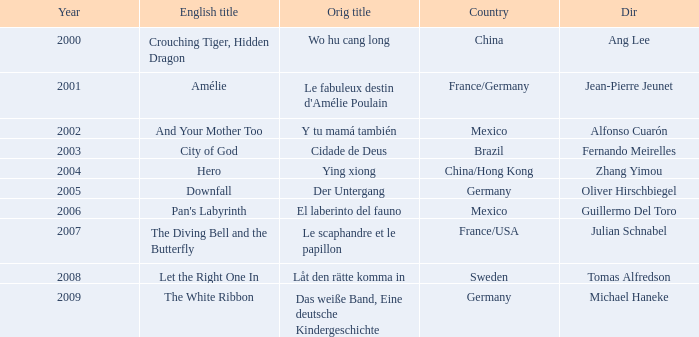Can you give me this table as a dict? {'header': ['Year', 'English title', 'Orig title', 'Country', 'Dir'], 'rows': [['2000', 'Crouching Tiger, Hidden Dragon', 'Wo hu cang long', 'China', 'Ang Lee'], ['2001', 'Amélie', "Le fabuleux destin d'Amélie Poulain", 'France/Germany', 'Jean-Pierre Jeunet'], ['2002', 'And Your Mother Too', 'Y tu mamá también', 'Mexico', 'Alfonso Cuarón'], ['2003', 'City of God', 'Cidade de Deus', 'Brazil', 'Fernando Meirelles'], ['2004', 'Hero', 'Ying xiong', 'China/Hong Kong', 'Zhang Yimou'], ['2005', 'Downfall', 'Der Untergang', 'Germany', 'Oliver Hirschbiegel'], ['2006', "Pan's Labyrinth", 'El laberinto del fauno', 'Mexico', 'Guillermo Del Toro'], ['2007', 'The Diving Bell and the Butterfly', 'Le scaphandre et le papillon', 'France/USA', 'Julian Schnabel'], ['2008', 'Let the Right One In', 'Låt den rätte komma in', 'Sweden', 'Tomas Alfredson'], ['2009', 'The White Ribbon', 'Das weiße Band, Eine deutsche Kindergeschichte', 'Germany', 'Michael Haneke']]} Specify the title connected to jean-pierre jeunet. Amélie. 